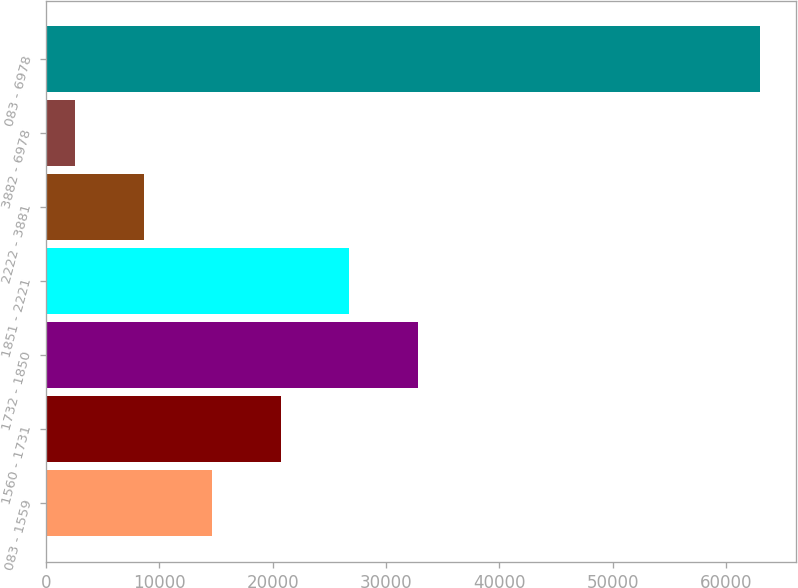Convert chart. <chart><loc_0><loc_0><loc_500><loc_500><bar_chart><fcel>083 - 1559<fcel>1560 - 1731<fcel>1732 - 1850<fcel>1851 - 2221<fcel>2222 - 3881<fcel>3882 - 6978<fcel>083 - 6978<nl><fcel>14678.4<fcel>20720.1<fcel>32803.5<fcel>26761.8<fcel>8636.7<fcel>2595<fcel>63012<nl></chart> 